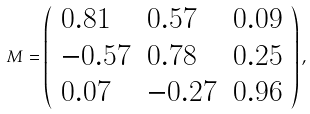<formula> <loc_0><loc_0><loc_500><loc_500>\text { } M = \left ( \begin{array} { l l l } 0 . 8 1 & 0 . 5 7 & 0 . 0 9 \\ - 0 . 5 7 & 0 . 7 8 & 0 . 2 5 \\ 0 . 0 7 & - 0 . 2 7 & 0 . 9 6 \end{array} \right ) ,</formula> 